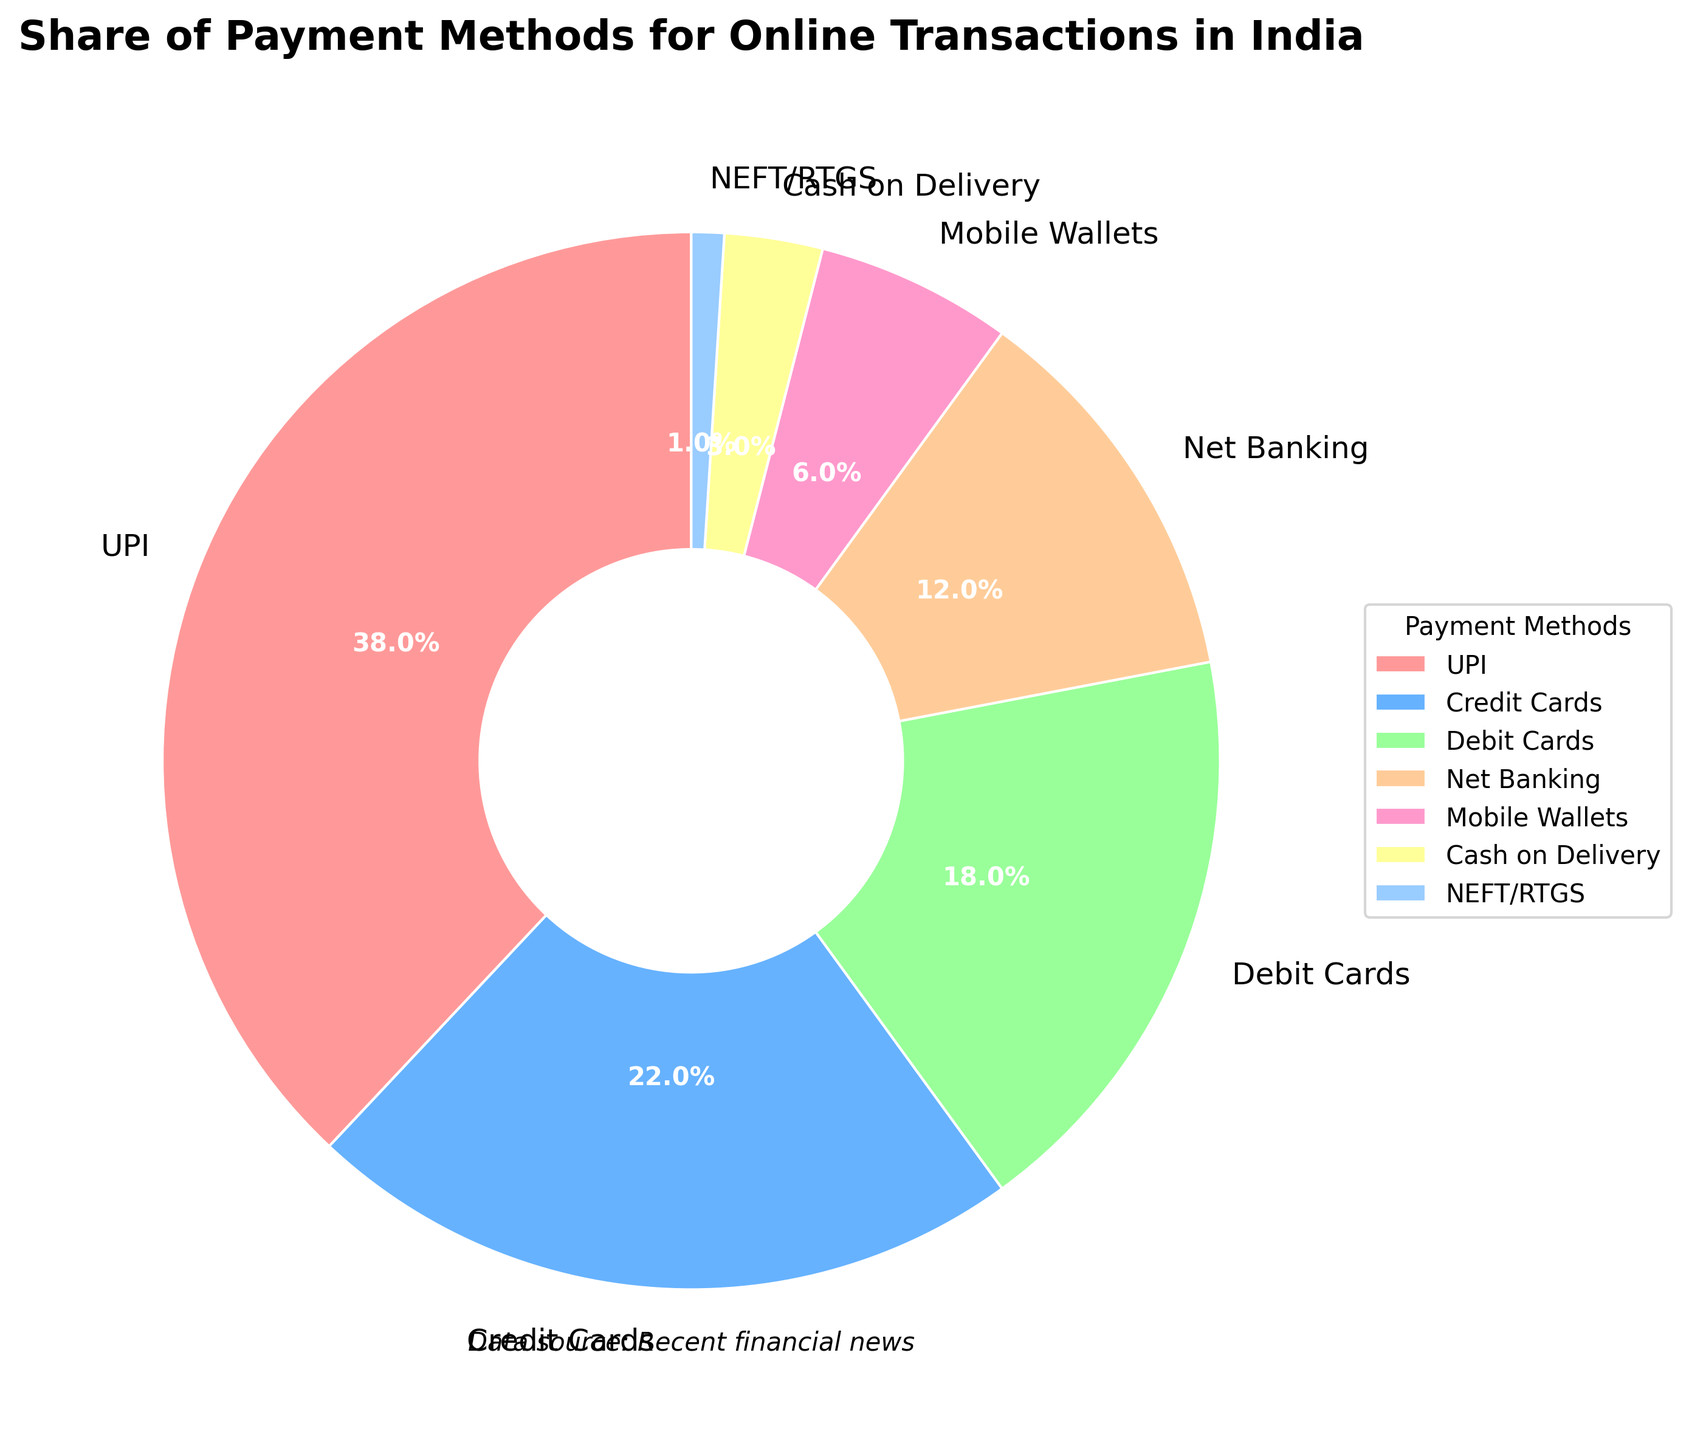Which payment method is most commonly used for online transactions in India? The figure shows that UPI has the largest slice of the pie chart, indicating it is the most commonly used payment method.
Answer: UPI What is the combined percentage share of credit and debit cards? The figure shows Credit Cards account for 22% and Debit Cards for 18%. Adding these percentages gives 22% + 18%.
Answer: 40% Which payment method has the second smallest share? The figure shows Net Banking has a 12% share, which is larger than Mobile Wallets (6%) and smaller than Debit Cards (18%). Therefore, Net Banking is the second smallest.
Answer: Net Banking How does the share of cash on delivery compare to NEFT/RTGS? The figure shows Cash on Delivery accounts for 3% and NEFT/RTGS for 1%. Therefore, Cash on Delivery has a greater share.
Answer: Cash on Delivery has a greater share What percentage of the pie chart is occupied by methods other than UPI? To find this, subtract the UPI percentage (38%) from the total (100%): 100% - 38%.
Answer: 62% Which sections of the pie chart are in green and blue shades? The figure shows that Debit Cards are green (18%) and Credit Cards are blue (22%).
Answer: Debit Cards and Credit Cards How much larger is the share of UPI compared to Mobile Wallets? The figure shows UPI has a 38% share and Mobile Wallets have 6%. The difference is 38% - 6%.
Answer: 32% Rank all payment methods from the highest to lowest share. Referring to the figure, the shares are: UPI (38%), Credit Cards (22%), Debit Cards (18%), Net Banking (12%), Mobile Wallets (6%), Cash on Delivery (3%), NEFT/RTGS (1%).
Answer: UPI, Credit Cards, Debit Cards, Net Banking, Mobile Wallets, Cash on Delivery, NEFT/RTGS What is the sum of the percentages of Net Banking and Cash on Delivery? The figure shows Net Banking at 12% and Cash on Delivery at 3%. Adding these gives 12% + 3%.
Answer: 15% What percentage of payment methods falls in the range of 5%-15%? From the figure, only Net Banking (12%) and Mobile Wallets (6%) fall into this range. Adding them up gives 12% + 6%.
Answer: 18% 